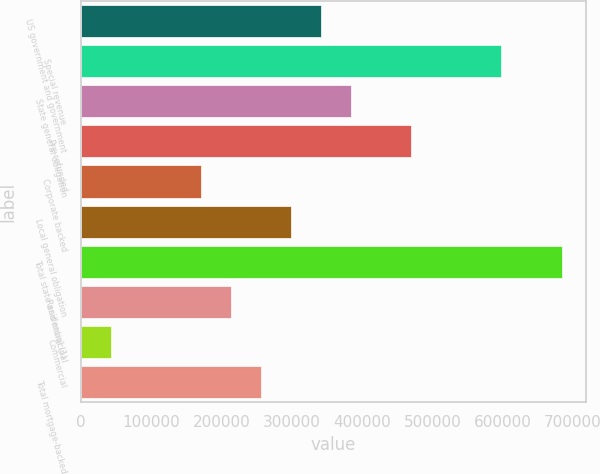Convert chart to OTSL. <chart><loc_0><loc_0><loc_500><loc_500><bar_chart><fcel>US government and government<fcel>Special revenue<fcel>State general obligation<fcel>Pre-refunded<fcel>Corporate backed<fcel>Local general obligation<fcel>Total state and municipal<fcel>Residential (1)<fcel>Commercial<fcel>Total mortgage-backed<nl><fcel>342043<fcel>598391<fcel>384767<fcel>470217<fcel>171144<fcel>299318<fcel>683840<fcel>213868<fcel>42969.7<fcel>256593<nl></chart> 